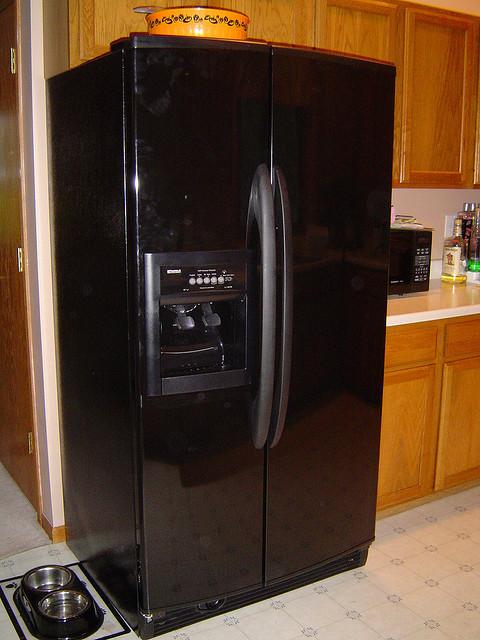What color are the cabinets?
Quick response, please. Brown. Is the homeowner also a pet owner?
Answer briefly. Yes. Does this fridge have an ice maker?
Be succinct. Yes. 